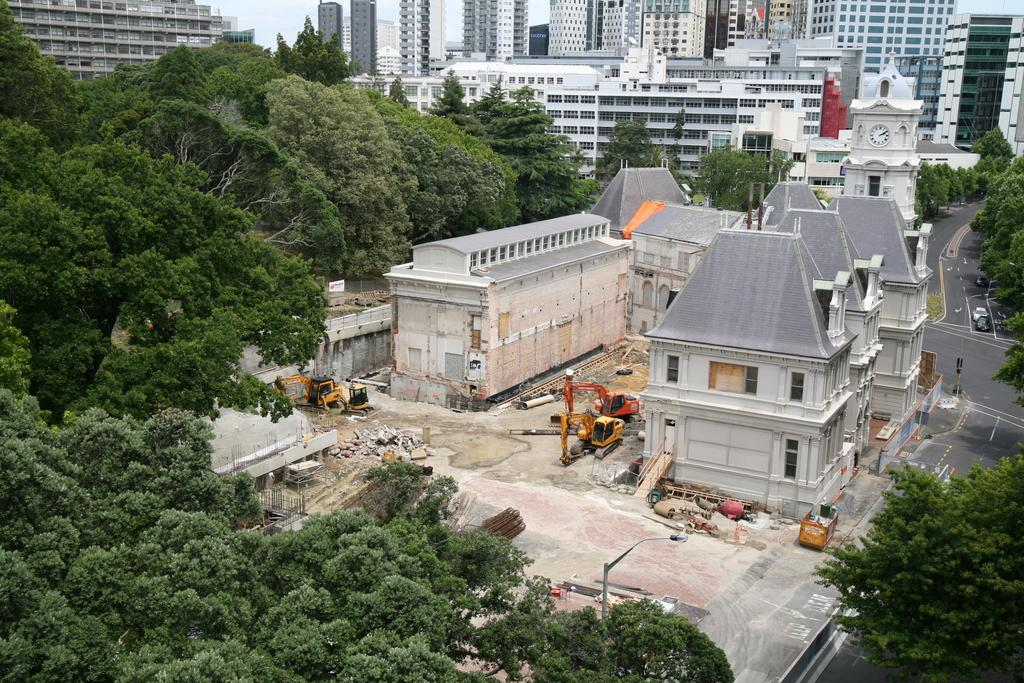What type of natural elements can be seen in the image? There are trees in the image. What man-made objects are present in the image? There are vehicles in the image. What can be seen in the background of the image? In the background, there are cars on the road and buildings. What part of the natural environment is visible in the image? The sky is visible in the background. Can you tell me how many hospitals are visible in the image? There is no hospital present in the image. Is there a bike being ridden by someone in the image? There is no bike or person riding a bike visible in the image. 